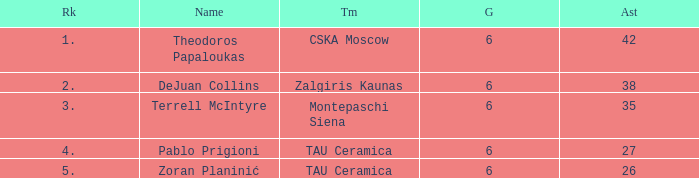What is the least number of assists among players ranked 2? 38.0. 